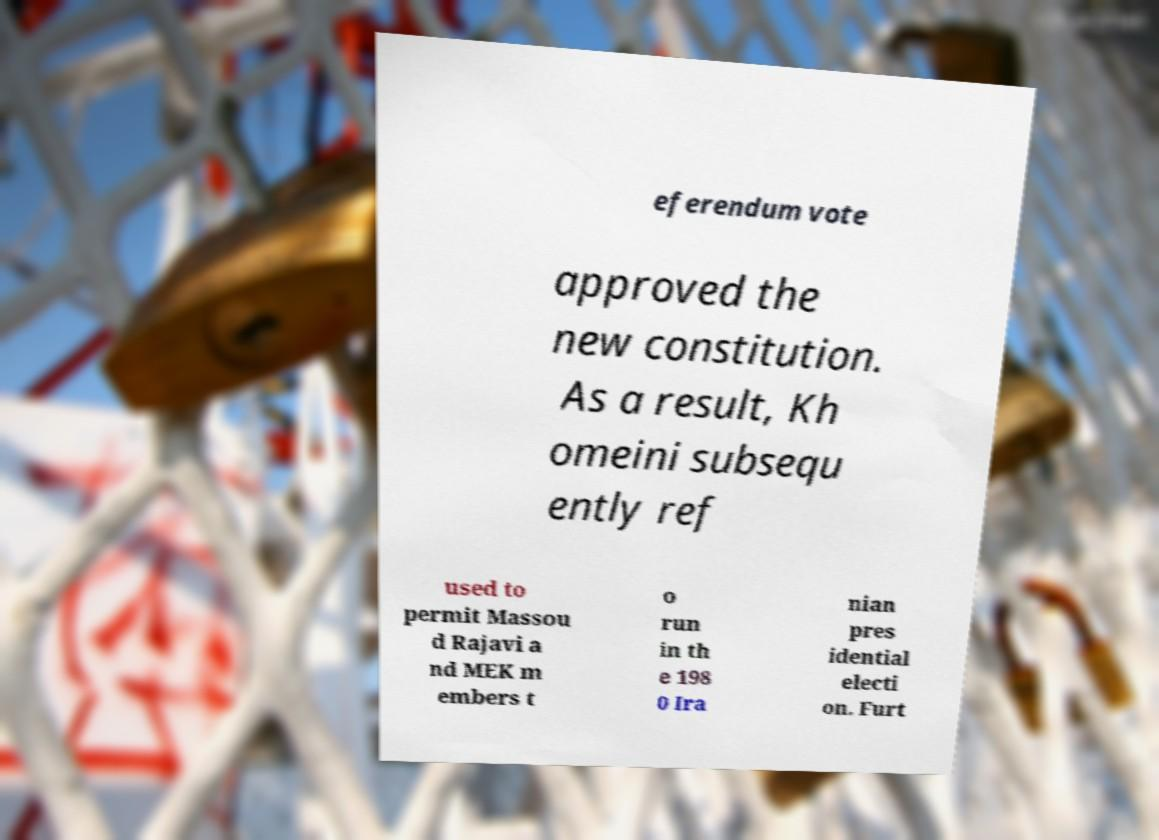There's text embedded in this image that I need extracted. Can you transcribe it verbatim? eferendum vote approved the new constitution. As a result, Kh omeini subsequ ently ref used to permit Massou d Rajavi a nd MEK m embers t o run in th e 198 0 Ira nian pres idential electi on. Furt 